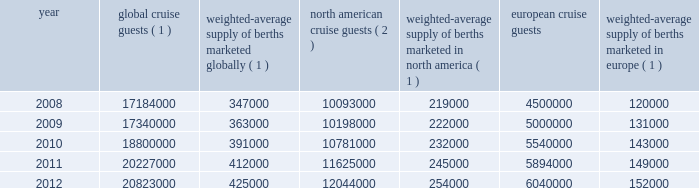Result of the effects of the costa concordia incident and the continued instability in the european eco- nomic landscape .
However , we continue to believe in the long term growth potential of this market .
We estimate that europe was served by 102 ships with approximately 108000 berths at the beginning of 2008 and by 117 ships with approximately 156000 berths at the end of 2012 .
There are approximately 9 ships with an estimated 25000 berths that are expected to be placed in service in the european cruise market between 2013 and 2017 .
The table details the growth in the global , north american and european cruise markets in terms of cruise guests and estimated weighted-average berths over the past five years : global cruise guests ( 1 ) weighted-average supply of berths marketed globally ( 1 ) north american cruise guests ( 2 ) weighted-average supply of berths marketed in north america ( 1 ) european cruise guests weighted-average supply of berths marketed in europe ( 1 ) .
( 1 ) source : our estimates of the number of global cruise guests , and the weighted-average supply of berths marketed globally , in north america and europe are based on a combination of data that we obtain from various publicly available cruise industry trade information sources including seatrade insider and cruise line international association ( 201cclia 201d ) .
In addition , our estimates incorporate our own statistical analysis utilizing the same publicly available cruise industry data as a base .
( 2 ) source : cruise line international association based on cruise guests carried for at least two consecutive nights for years 2008 through 2011 .
Year 2012 amounts represent our estimates ( see number 1 above ) .
( 3 ) source : clia europe , formerly european cruise council , for years 2008 through 2011 .
Year 2012 amounts represent our estimates ( see number 1 above ) .
Other markets in addition to expected industry growth in north america and europe as discussed above , we expect the asia/pacific region to demonstrate an even higher growth rate in the near term , although it will continue to represent a relatively small sector compared to north america and europe .
Competition we compete with a number of cruise lines .
Our princi- pal competitors are carnival corporation & plc , which owns , among others , aida cruises , carnival cruise lines , costa cruises , cunard line , holland america line , iberocruceros , p&o cruises and princess cruises ; disney cruise line ; msc cruises ; norwegian cruise line and oceania cruises .
Cruise lines compete with other vacation alternatives such as land-based resort hotels and sightseeing destinations for consumers 2019 leisure time .
Demand for such activities is influenced by political and general economic conditions .
Com- panies within the vacation market are dependent on consumer discretionary spending .
Operating strategies our principal operating strategies are to : 2022 protect the health , safety and security of our guests and employees and protect the environment in which our vessels and organization operate , 2022 strengthen and support our human capital in order to better serve our global guest base and grow our business , 2022 further strengthen our consumer engagement in order to enhance our revenues , 2022 increase the awareness and market penetration of our brands globally , 2022 focus on cost efficiency , manage our operating expenditures and ensure adequate cash and liquid- ity , with the overall goal of maximizing our return on invested capital and long-term shareholder value , 2022 strategically invest in our fleet through the revit ad alization of existing ships and the transfer of key innovations across each brand , while prudently expanding our fleet with the new state-of-the-art cruise ships recently delivered and on order , 2022 capitalize on the portability and flexibility of our ships by deploying them into those markets and itineraries that provide opportunities to optimize returns , while continuing our focus on existing key markets , 2022 further enhance our technological capabilities to service customer preferences and expectations in an innovative manner , while supporting our strategic focus on profitability , and part i 0494.indd 13 3/27/13 12:52 pm .
What was the percentage increase of global cruise guests from 2008-2012? 
Computations: (((20823000 - 17184000) / 17184000) * 100)
Answer: 21.17668. 